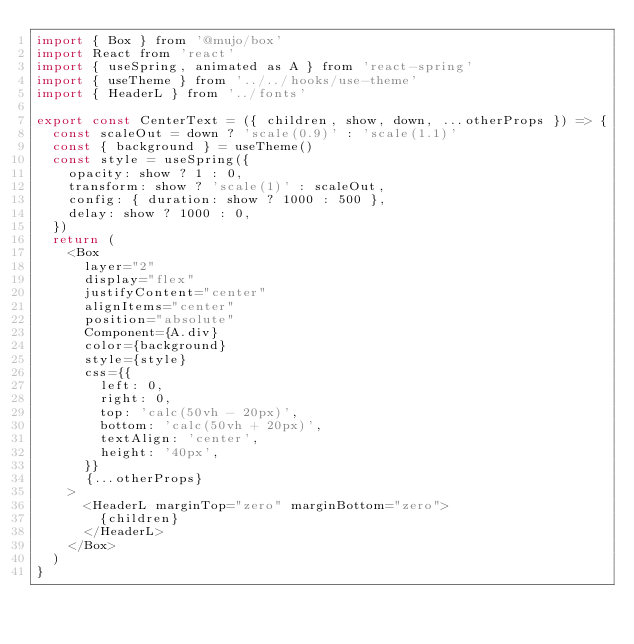<code> <loc_0><loc_0><loc_500><loc_500><_JavaScript_>import { Box } from '@mujo/box'
import React from 'react'
import { useSpring, animated as A } from 'react-spring'
import { useTheme } from '../../hooks/use-theme'
import { HeaderL } from '../fonts'

export const CenterText = ({ children, show, down, ...otherProps }) => {
  const scaleOut = down ? 'scale(0.9)' : 'scale(1.1)'
  const { background } = useTheme()
  const style = useSpring({
    opacity: show ? 1 : 0,
    transform: show ? 'scale(1)' : scaleOut,
    config: { duration: show ? 1000 : 500 },
    delay: show ? 1000 : 0,
  })
  return (
    <Box
      layer="2"
      display="flex"
      justifyContent="center"
      alignItems="center"
      position="absolute"
      Component={A.div}
      color={background}
      style={style}
      css={{
        left: 0,
        right: 0,
        top: 'calc(50vh - 20px)',
        bottom: 'calc(50vh + 20px)',
        textAlign: 'center',
        height: '40px',
      }}
      {...otherProps}
    >
      <HeaderL marginTop="zero" marginBottom="zero">
        {children}
      </HeaderL>
    </Box>
  )
}
</code> 